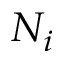Convert formula to latex. <formula><loc_0><loc_0><loc_500><loc_500>N _ { i }</formula> 